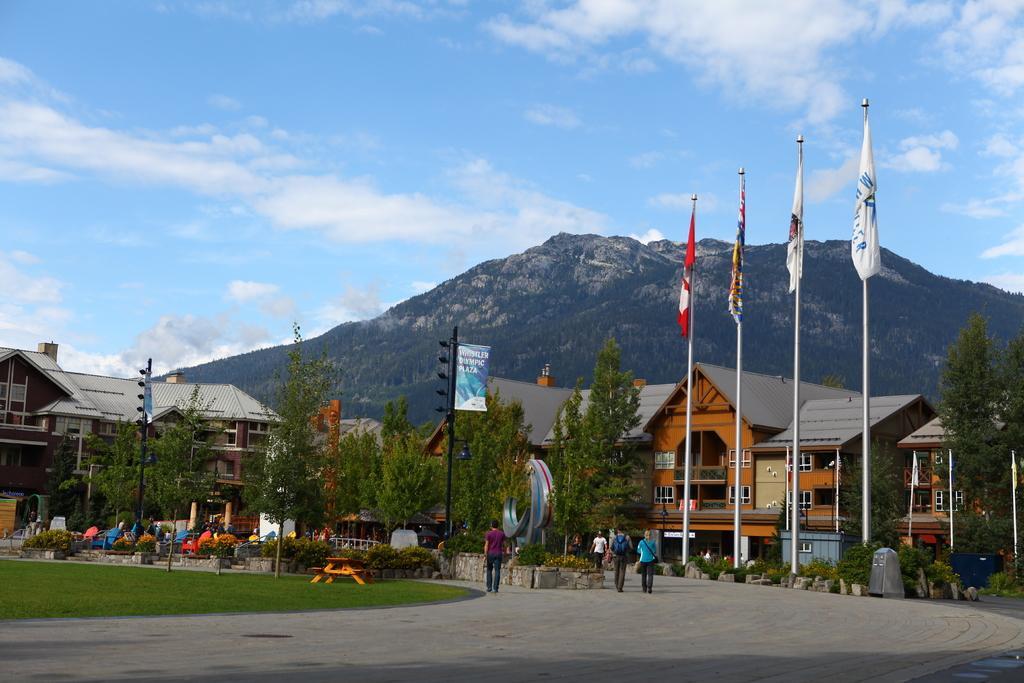Please provide a concise description of this image. In this image we can see group of persons standing on the ground. One person is wearing a bag. To the right side of the image we can see group of flags placed on poles,building and some trees. In the left side of the image we can see a bench placed on the grass ,group of trees ,building and in the background we can see mountain and a cloudy sky. 